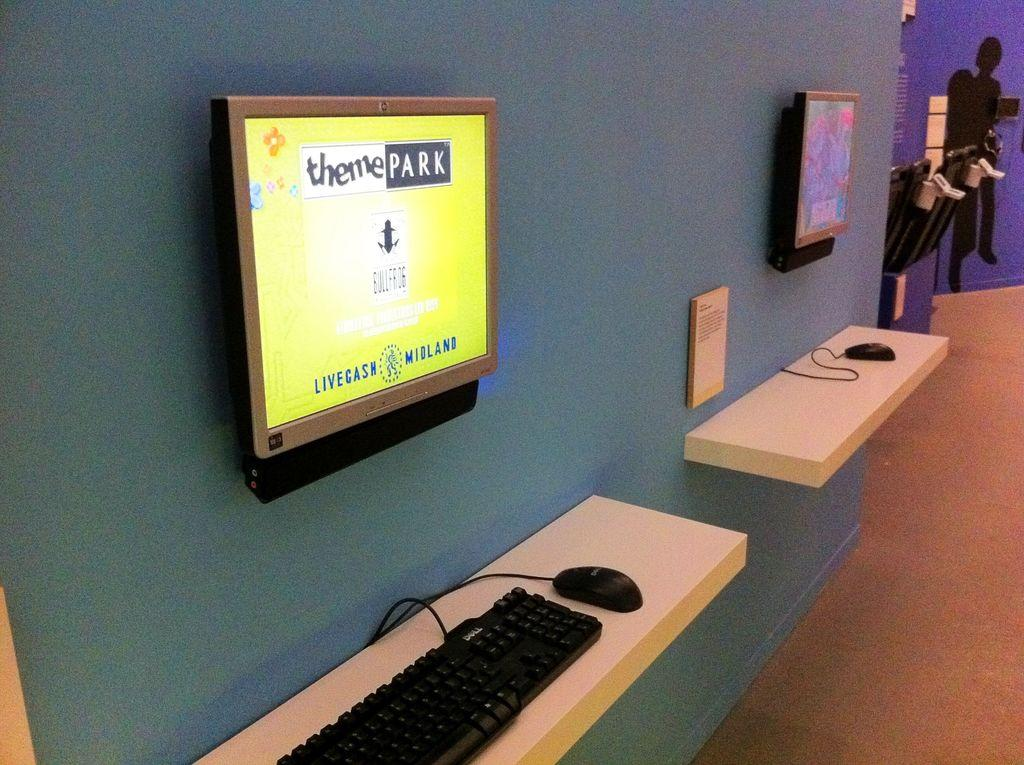<image>
Give a short and clear explanation of the subsequent image. A wall mounted screen brightly displays some theme park information. 